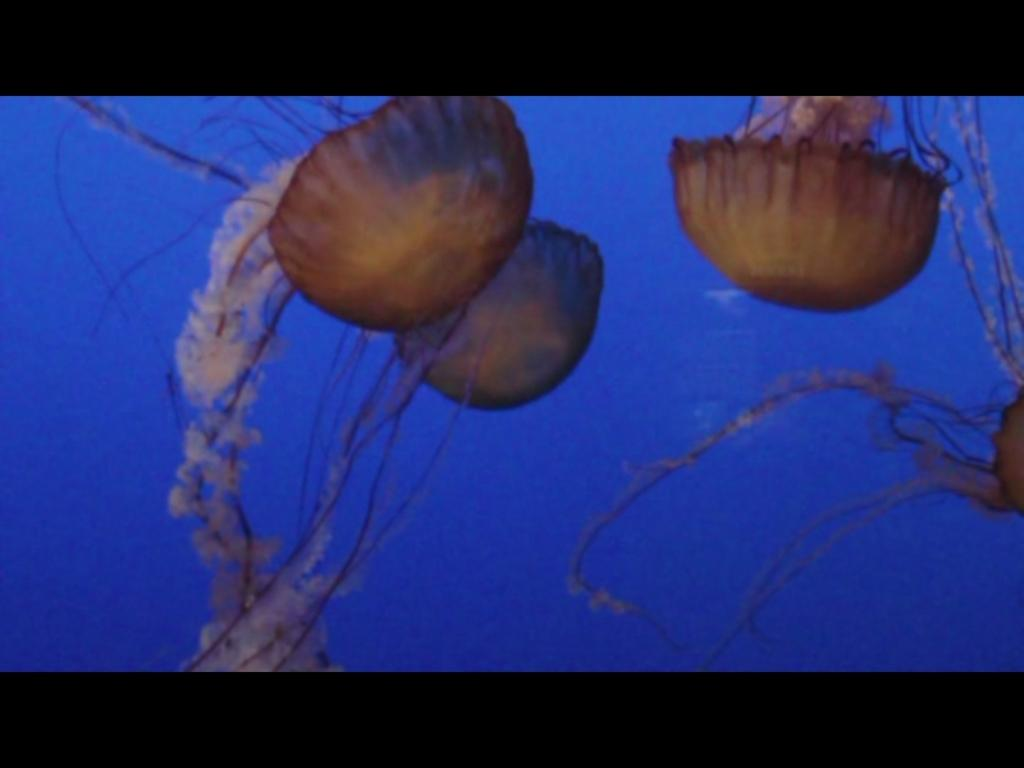What type of animals are in the image? There are jellyfishes in the image. Where are the jellyfishes located? The jellyfishes are in the water. What time does the farmer watch the jellyfishes in the image? There is no farmer or time mentioned in the image; it only features jellyfishes in the water. 